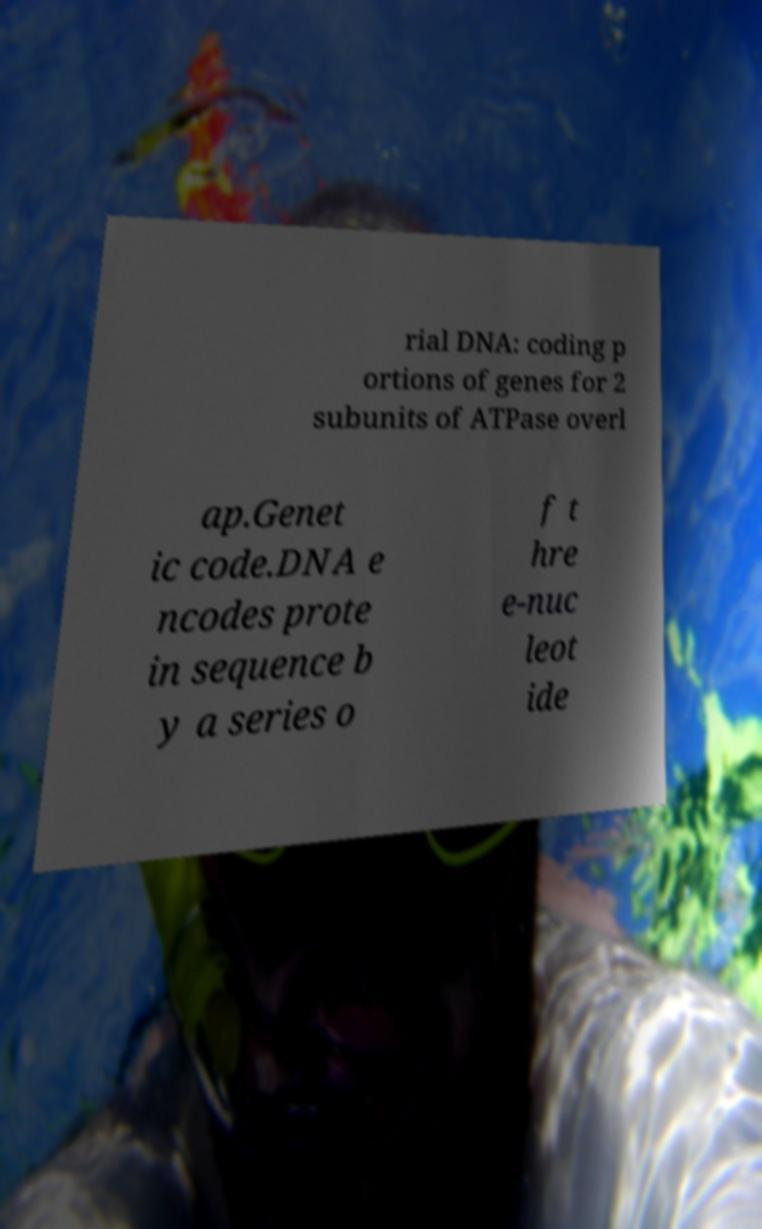Could you extract and type out the text from this image? rial DNA: coding p ortions of genes for 2 subunits of ATPase overl ap.Genet ic code.DNA e ncodes prote in sequence b y a series o f t hre e-nuc leot ide 